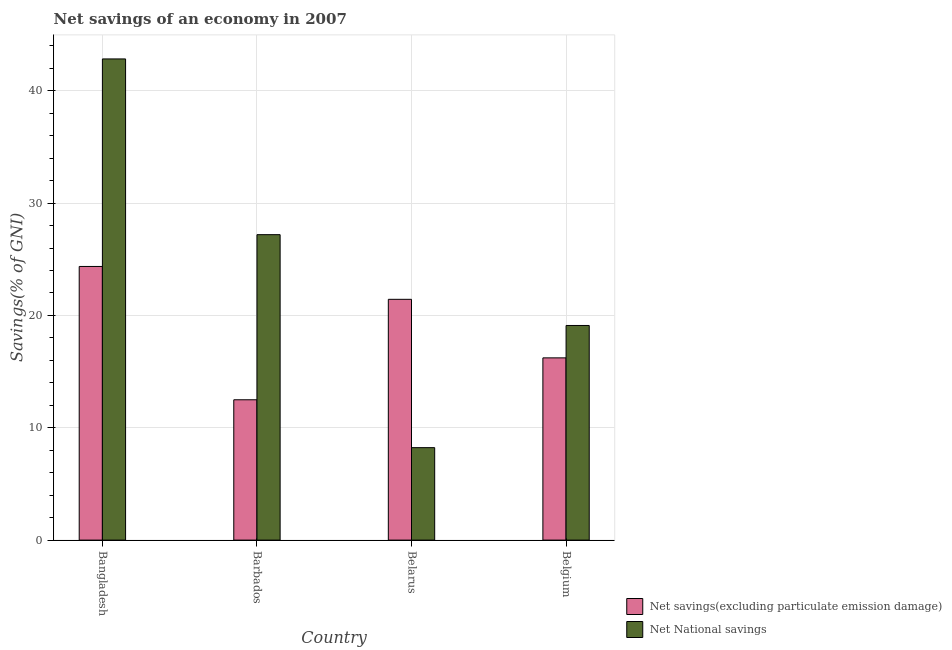Are the number of bars per tick equal to the number of legend labels?
Provide a succinct answer. Yes. How many bars are there on the 2nd tick from the right?
Give a very brief answer. 2. What is the label of the 3rd group of bars from the left?
Your answer should be compact. Belarus. What is the net national savings in Belarus?
Offer a very short reply. 8.23. Across all countries, what is the maximum net national savings?
Provide a short and direct response. 42.84. Across all countries, what is the minimum net national savings?
Make the answer very short. 8.23. In which country was the net national savings minimum?
Provide a succinct answer. Belarus. What is the total net national savings in the graph?
Your answer should be very brief. 97.37. What is the difference between the net savings(excluding particulate emission damage) in Bangladesh and that in Belgium?
Your response must be concise. 8.14. What is the difference between the net national savings in Bangladesh and the net savings(excluding particulate emission damage) in Belgium?
Ensure brevity in your answer.  26.61. What is the average net savings(excluding particulate emission damage) per country?
Offer a terse response. 18.63. What is the difference between the net savings(excluding particulate emission damage) and net national savings in Barbados?
Provide a short and direct response. -14.7. In how many countries, is the net savings(excluding particulate emission damage) greater than 18 %?
Make the answer very short. 2. What is the ratio of the net savings(excluding particulate emission damage) in Barbados to that in Belgium?
Provide a succinct answer. 0.77. Is the net savings(excluding particulate emission damage) in Barbados less than that in Belarus?
Your response must be concise. Yes. Is the difference between the net national savings in Belarus and Belgium greater than the difference between the net savings(excluding particulate emission damage) in Belarus and Belgium?
Your response must be concise. No. What is the difference between the highest and the second highest net national savings?
Keep it short and to the point. 15.64. What is the difference between the highest and the lowest net national savings?
Offer a terse response. 34.61. Is the sum of the net savings(excluding particulate emission damage) in Bangladesh and Belarus greater than the maximum net national savings across all countries?
Offer a terse response. Yes. What does the 1st bar from the left in Bangladesh represents?
Give a very brief answer. Net savings(excluding particulate emission damage). What does the 2nd bar from the right in Belgium represents?
Keep it short and to the point. Net savings(excluding particulate emission damage). How many bars are there?
Provide a succinct answer. 8. How many countries are there in the graph?
Your response must be concise. 4. Are the values on the major ticks of Y-axis written in scientific E-notation?
Your response must be concise. No. Does the graph contain any zero values?
Offer a terse response. No. Does the graph contain grids?
Offer a very short reply. Yes. Where does the legend appear in the graph?
Your answer should be compact. Bottom right. How many legend labels are there?
Your answer should be compact. 2. What is the title of the graph?
Make the answer very short. Net savings of an economy in 2007. What is the label or title of the X-axis?
Ensure brevity in your answer.  Country. What is the label or title of the Y-axis?
Offer a very short reply. Savings(% of GNI). What is the Savings(% of GNI) in Net savings(excluding particulate emission damage) in Bangladesh?
Provide a short and direct response. 24.36. What is the Savings(% of GNI) in Net National savings in Bangladesh?
Provide a short and direct response. 42.84. What is the Savings(% of GNI) in Net savings(excluding particulate emission damage) in Barbados?
Keep it short and to the point. 12.49. What is the Savings(% of GNI) of Net National savings in Barbados?
Keep it short and to the point. 27.19. What is the Savings(% of GNI) in Net savings(excluding particulate emission damage) in Belarus?
Provide a succinct answer. 21.44. What is the Savings(% of GNI) of Net National savings in Belarus?
Ensure brevity in your answer.  8.23. What is the Savings(% of GNI) of Net savings(excluding particulate emission damage) in Belgium?
Provide a succinct answer. 16.22. What is the Savings(% of GNI) of Net National savings in Belgium?
Your answer should be very brief. 19.11. Across all countries, what is the maximum Savings(% of GNI) of Net savings(excluding particulate emission damage)?
Keep it short and to the point. 24.36. Across all countries, what is the maximum Savings(% of GNI) of Net National savings?
Your answer should be compact. 42.84. Across all countries, what is the minimum Savings(% of GNI) in Net savings(excluding particulate emission damage)?
Provide a succinct answer. 12.49. Across all countries, what is the minimum Savings(% of GNI) in Net National savings?
Offer a very short reply. 8.23. What is the total Savings(% of GNI) in Net savings(excluding particulate emission damage) in the graph?
Offer a terse response. 74.51. What is the total Savings(% of GNI) of Net National savings in the graph?
Your answer should be compact. 97.37. What is the difference between the Savings(% of GNI) in Net savings(excluding particulate emission damage) in Bangladesh and that in Barbados?
Offer a terse response. 11.87. What is the difference between the Savings(% of GNI) in Net National savings in Bangladesh and that in Barbados?
Offer a terse response. 15.64. What is the difference between the Savings(% of GNI) of Net savings(excluding particulate emission damage) in Bangladesh and that in Belarus?
Offer a very short reply. 2.93. What is the difference between the Savings(% of GNI) of Net National savings in Bangladesh and that in Belarus?
Your response must be concise. 34.61. What is the difference between the Savings(% of GNI) of Net savings(excluding particulate emission damage) in Bangladesh and that in Belgium?
Offer a very short reply. 8.14. What is the difference between the Savings(% of GNI) of Net National savings in Bangladesh and that in Belgium?
Your response must be concise. 23.73. What is the difference between the Savings(% of GNI) of Net savings(excluding particulate emission damage) in Barbados and that in Belarus?
Make the answer very short. -8.94. What is the difference between the Savings(% of GNI) in Net National savings in Barbados and that in Belarus?
Offer a very short reply. 18.96. What is the difference between the Savings(% of GNI) in Net savings(excluding particulate emission damage) in Barbados and that in Belgium?
Give a very brief answer. -3.73. What is the difference between the Savings(% of GNI) in Net National savings in Barbados and that in Belgium?
Keep it short and to the point. 8.09. What is the difference between the Savings(% of GNI) of Net savings(excluding particulate emission damage) in Belarus and that in Belgium?
Your answer should be compact. 5.21. What is the difference between the Savings(% of GNI) in Net National savings in Belarus and that in Belgium?
Make the answer very short. -10.88. What is the difference between the Savings(% of GNI) of Net savings(excluding particulate emission damage) in Bangladesh and the Savings(% of GNI) of Net National savings in Barbados?
Your answer should be compact. -2.83. What is the difference between the Savings(% of GNI) of Net savings(excluding particulate emission damage) in Bangladesh and the Savings(% of GNI) of Net National savings in Belarus?
Provide a short and direct response. 16.13. What is the difference between the Savings(% of GNI) in Net savings(excluding particulate emission damage) in Bangladesh and the Savings(% of GNI) in Net National savings in Belgium?
Keep it short and to the point. 5.25. What is the difference between the Savings(% of GNI) in Net savings(excluding particulate emission damage) in Barbados and the Savings(% of GNI) in Net National savings in Belarus?
Your response must be concise. 4.26. What is the difference between the Savings(% of GNI) in Net savings(excluding particulate emission damage) in Barbados and the Savings(% of GNI) in Net National savings in Belgium?
Make the answer very short. -6.61. What is the difference between the Savings(% of GNI) of Net savings(excluding particulate emission damage) in Belarus and the Savings(% of GNI) of Net National savings in Belgium?
Ensure brevity in your answer.  2.33. What is the average Savings(% of GNI) in Net savings(excluding particulate emission damage) per country?
Make the answer very short. 18.63. What is the average Savings(% of GNI) of Net National savings per country?
Your answer should be compact. 24.34. What is the difference between the Savings(% of GNI) of Net savings(excluding particulate emission damage) and Savings(% of GNI) of Net National savings in Bangladesh?
Your response must be concise. -18.48. What is the difference between the Savings(% of GNI) in Net savings(excluding particulate emission damage) and Savings(% of GNI) in Net National savings in Barbados?
Your answer should be very brief. -14.7. What is the difference between the Savings(% of GNI) of Net savings(excluding particulate emission damage) and Savings(% of GNI) of Net National savings in Belarus?
Offer a terse response. 13.21. What is the difference between the Savings(% of GNI) of Net savings(excluding particulate emission damage) and Savings(% of GNI) of Net National savings in Belgium?
Your response must be concise. -2.88. What is the ratio of the Savings(% of GNI) in Net savings(excluding particulate emission damage) in Bangladesh to that in Barbados?
Provide a short and direct response. 1.95. What is the ratio of the Savings(% of GNI) in Net National savings in Bangladesh to that in Barbados?
Your response must be concise. 1.58. What is the ratio of the Savings(% of GNI) of Net savings(excluding particulate emission damage) in Bangladesh to that in Belarus?
Offer a terse response. 1.14. What is the ratio of the Savings(% of GNI) of Net National savings in Bangladesh to that in Belarus?
Offer a very short reply. 5.2. What is the ratio of the Savings(% of GNI) in Net savings(excluding particulate emission damage) in Bangladesh to that in Belgium?
Offer a terse response. 1.5. What is the ratio of the Savings(% of GNI) in Net National savings in Bangladesh to that in Belgium?
Keep it short and to the point. 2.24. What is the ratio of the Savings(% of GNI) in Net savings(excluding particulate emission damage) in Barbados to that in Belarus?
Your response must be concise. 0.58. What is the ratio of the Savings(% of GNI) of Net National savings in Barbados to that in Belarus?
Your answer should be compact. 3.3. What is the ratio of the Savings(% of GNI) in Net savings(excluding particulate emission damage) in Barbados to that in Belgium?
Provide a short and direct response. 0.77. What is the ratio of the Savings(% of GNI) of Net National savings in Barbados to that in Belgium?
Provide a short and direct response. 1.42. What is the ratio of the Savings(% of GNI) in Net savings(excluding particulate emission damage) in Belarus to that in Belgium?
Provide a succinct answer. 1.32. What is the ratio of the Savings(% of GNI) in Net National savings in Belarus to that in Belgium?
Make the answer very short. 0.43. What is the difference between the highest and the second highest Savings(% of GNI) in Net savings(excluding particulate emission damage)?
Your answer should be very brief. 2.93. What is the difference between the highest and the second highest Savings(% of GNI) in Net National savings?
Offer a terse response. 15.64. What is the difference between the highest and the lowest Savings(% of GNI) of Net savings(excluding particulate emission damage)?
Give a very brief answer. 11.87. What is the difference between the highest and the lowest Savings(% of GNI) of Net National savings?
Offer a terse response. 34.61. 